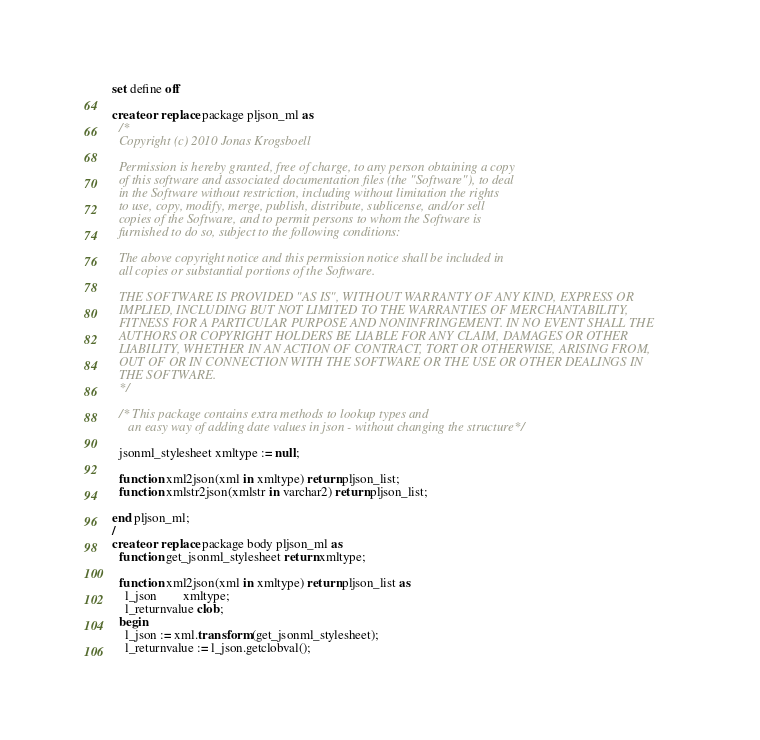Convert code to text. <code><loc_0><loc_0><loc_500><loc_500><_SQL_>set define off

create or replace package pljson_ml as
  /*
  Copyright (c) 2010 Jonas Krogsboell

  Permission is hereby granted, free of charge, to any person obtaining a copy
  of this software and associated documentation files (the "Software"), to deal
  in the Software without restriction, including without limitation the rights
  to use, copy, modify, merge, publish, distribute, sublicense, and/or sell
  copies of the Software, and to permit persons to whom the Software is
  furnished to do so, subject to the following conditions:

  The above copyright notice and this permission notice shall be included in
  all copies or substantial portions of the Software.

  THE SOFTWARE IS PROVIDED "AS IS", WITHOUT WARRANTY OF ANY KIND, EXPRESS OR
  IMPLIED, INCLUDING BUT NOT LIMITED TO THE WARRANTIES OF MERCHANTABILITY,
  FITNESS FOR A PARTICULAR PURPOSE AND NONINFRINGEMENT. IN NO EVENT SHALL THE
  AUTHORS OR COPYRIGHT HOLDERS BE LIABLE FOR ANY CLAIM, DAMAGES OR OTHER
  LIABILITY, WHETHER IN AN ACTION OF CONTRACT, TORT OR OTHERWISE, ARISING FROM,
  OUT OF OR IN CONNECTION WITH THE SOFTWARE OR THE USE OR OTHER DEALINGS IN
  THE SOFTWARE.
  */
  
  /* This package contains extra methods to lookup types and
     an easy way of adding date values in json - without changing the structure */

  jsonml_stylesheet xmltype := null;

  function xml2json(xml in xmltype) return pljson_list;
  function xmlstr2json(xmlstr in varchar2) return pljson_list;

end pljson_ml;
/
create or replace package body pljson_ml as
  function get_jsonml_stylesheet return xmltype;

  function xml2json(xml in xmltype) return pljson_list as
    l_json        xmltype;
    l_returnvalue clob;
  begin
    l_json := xml.transform (get_jsonml_stylesheet);
    l_returnvalue := l_json.getclobval();</code> 